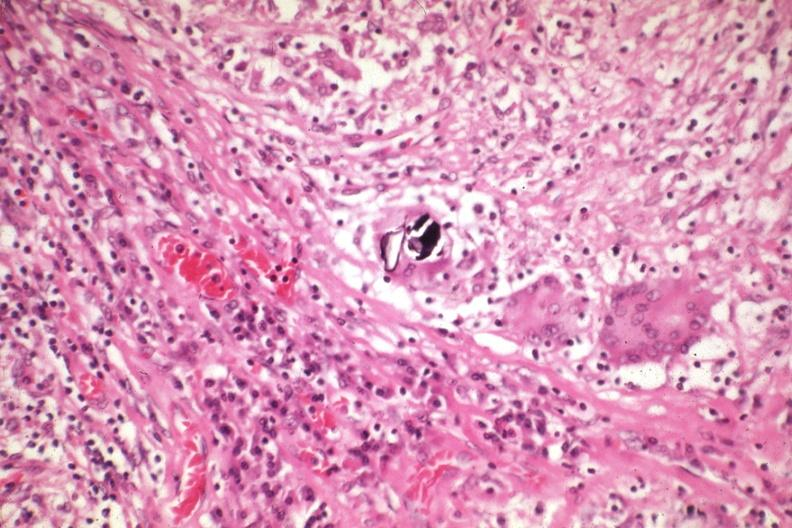what is present?
Answer the question using a single word or phrase. Lymph node 